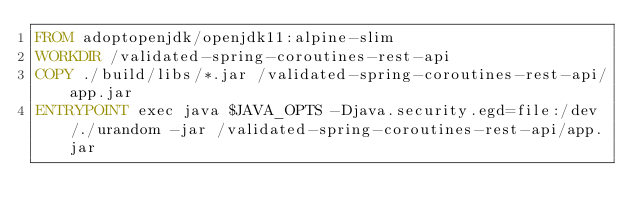Convert code to text. <code><loc_0><loc_0><loc_500><loc_500><_Dockerfile_>FROM adoptopenjdk/openjdk11:alpine-slim
WORKDIR /validated-spring-coroutines-rest-api
COPY ./build/libs/*.jar /validated-spring-coroutines-rest-api/app.jar
ENTRYPOINT exec java $JAVA_OPTS -Djava.security.egd=file:/dev/./urandom -jar /validated-spring-coroutines-rest-api/app.jar
</code> 